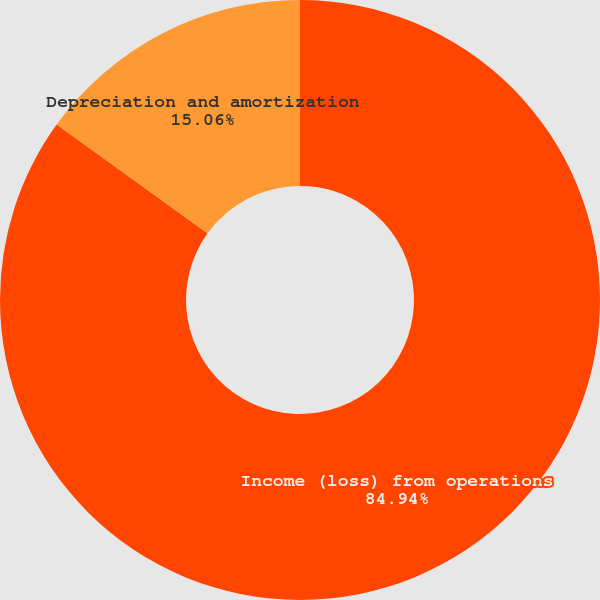<chart> <loc_0><loc_0><loc_500><loc_500><pie_chart><fcel>Income (loss) from operations<fcel>Depreciation and amortization<nl><fcel>84.94%<fcel>15.06%<nl></chart> 